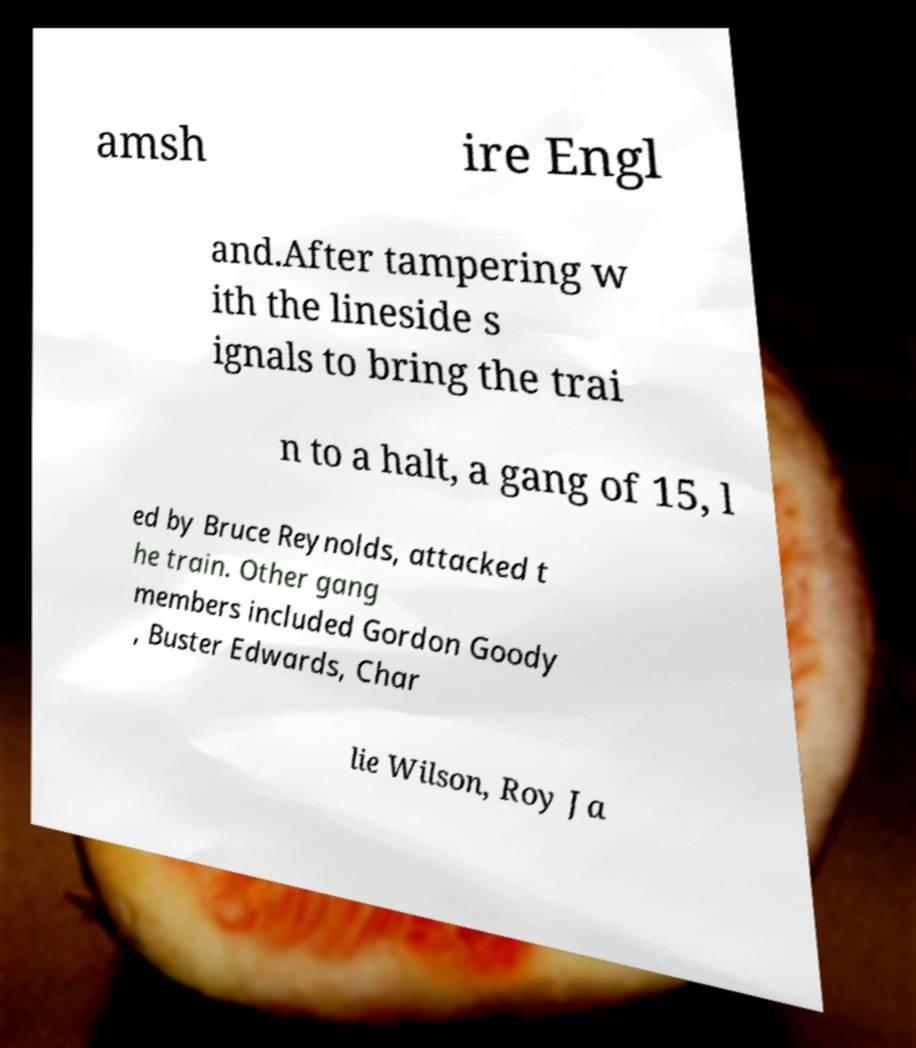For documentation purposes, I need the text within this image transcribed. Could you provide that? amsh ire Engl and.After tampering w ith the lineside s ignals to bring the trai n to a halt, a gang of 15, l ed by Bruce Reynolds, attacked t he train. Other gang members included Gordon Goody , Buster Edwards, Char lie Wilson, Roy Ja 